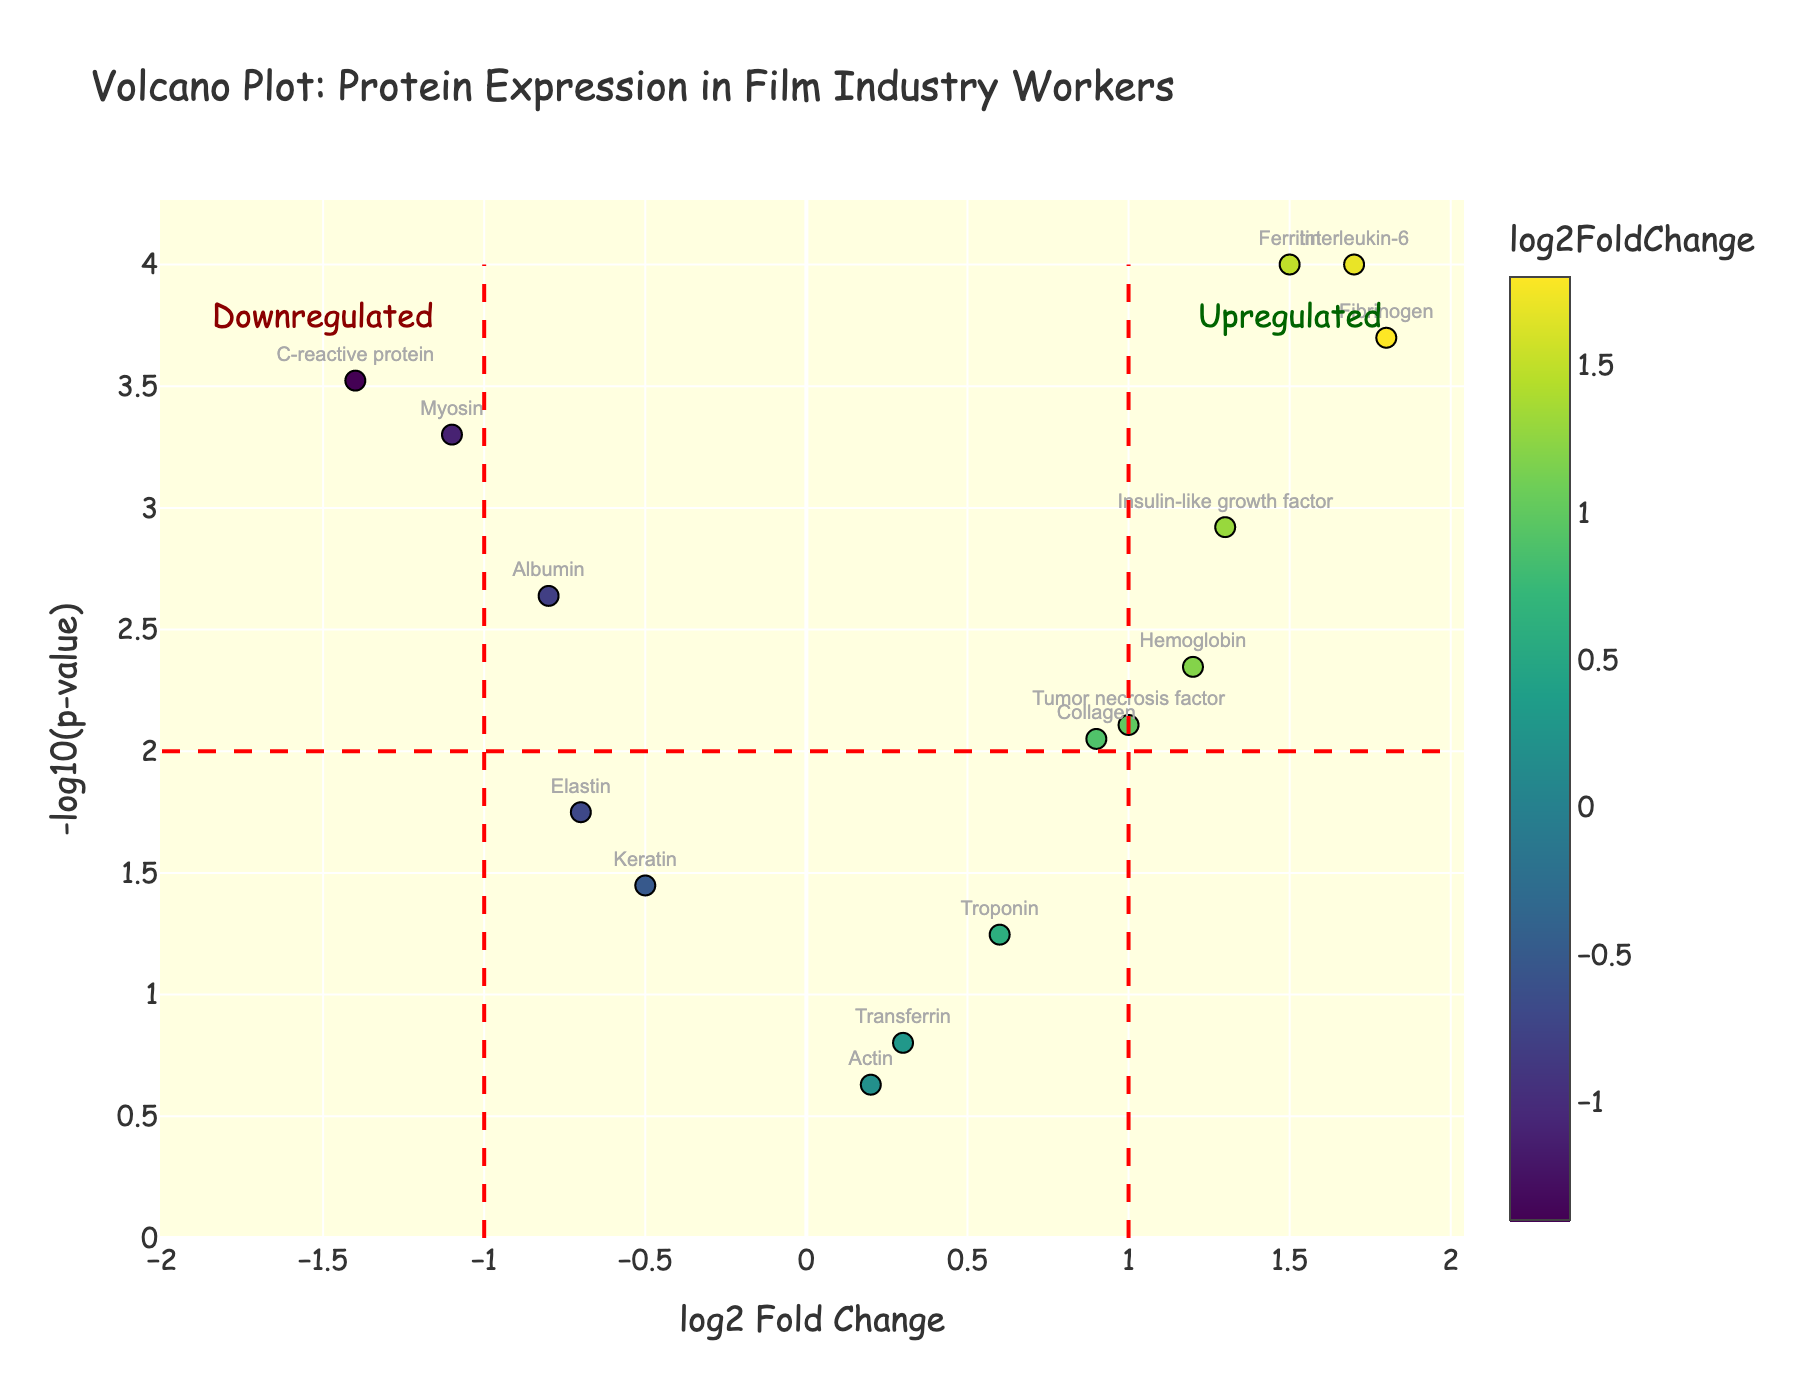What's the title of the figure? The title can be read directly from the figure's top, which states the subject of the plot.
Answer: Volcano Plot: Protein Expression in Film Industry Workers What's the x-axis representing in the plot? The x-axis shows 'log2 Fold Change', indicating the change in protein expression levels between two conditions on a logarithmic scale.
Answer: log2 Fold Change Which protein has the highest upregulation according to the plot? The highest upregulation is identified by finding the data point (protein) farthest to the right on the x-axis, and Fibrinogen at log2FoldChange of 1.8 is the furthest.
Answer: Fibrinogen How many proteins show significant downregulation? Significant downregulation can be determined by looking at the data points to the left of the x = -1 line and above the y = 2 line. From the figure, Myosin, Albumin, and C-reactive protein are downregulated significantly.
Answer: 3 What does the color scale in the plot represent? The color scale is used to visualize the log2 Fold Change values, with different colors representing different ranges of fold change, as indicated by the color bar on the right.
Answer: log2 Fold Change What is indicated by proteins that are positioned at the top left and top right corners of the plot? The top left denotes highly significant downregulation, and the top right denotes highly significant upregulation, shown by higher -log10(p-value) and extreme log2 Fold Change values in respective directions.
Answer: Highly significant downregulation and upregulation Which proteins are significantly upregulated in the workers and are above the 2 threshold for -log10(p-value)? To find these proteins, look to the right of the x = 1 line and above the y = 2 line: Ferritin, Fibrinogen, Insulin-like growth factor, Interleukin-6, and Tumor necrosis factor fit this criterion.
Answer: Ferritin, Fibrinogen, Insulin-like growth factor, Interleukin-6, Tumor necrosis factor Which protein is closer to the significance threshold but not quite significant for downregulation? Elastin is close to the significance line for downregulation as it sits just below the threshold line at -log10(p-value) around 1.75 and log2FoldChange around -0.7.
Answer: Elastin Why are significance lines at x = -1, x = 1, and y = 2 included in the plot? They demarcate thresholds for biologically significant fold change and statistical significance in -log10(p-value), making it easier to distinguish significant genes.
Answer: Thresholds for significance 